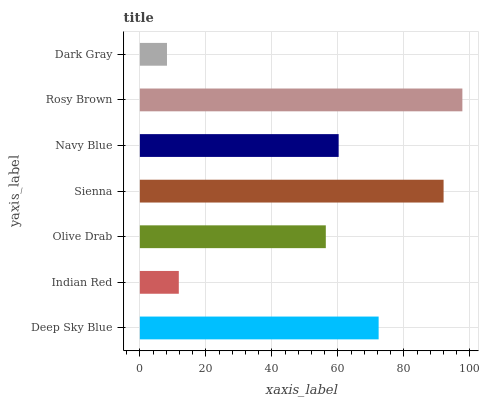Is Dark Gray the minimum?
Answer yes or no. Yes. Is Rosy Brown the maximum?
Answer yes or no. Yes. Is Indian Red the minimum?
Answer yes or no. No. Is Indian Red the maximum?
Answer yes or no. No. Is Deep Sky Blue greater than Indian Red?
Answer yes or no. Yes. Is Indian Red less than Deep Sky Blue?
Answer yes or no. Yes. Is Indian Red greater than Deep Sky Blue?
Answer yes or no. No. Is Deep Sky Blue less than Indian Red?
Answer yes or no. No. Is Navy Blue the high median?
Answer yes or no. Yes. Is Navy Blue the low median?
Answer yes or no. Yes. Is Indian Red the high median?
Answer yes or no. No. Is Rosy Brown the low median?
Answer yes or no. No. 